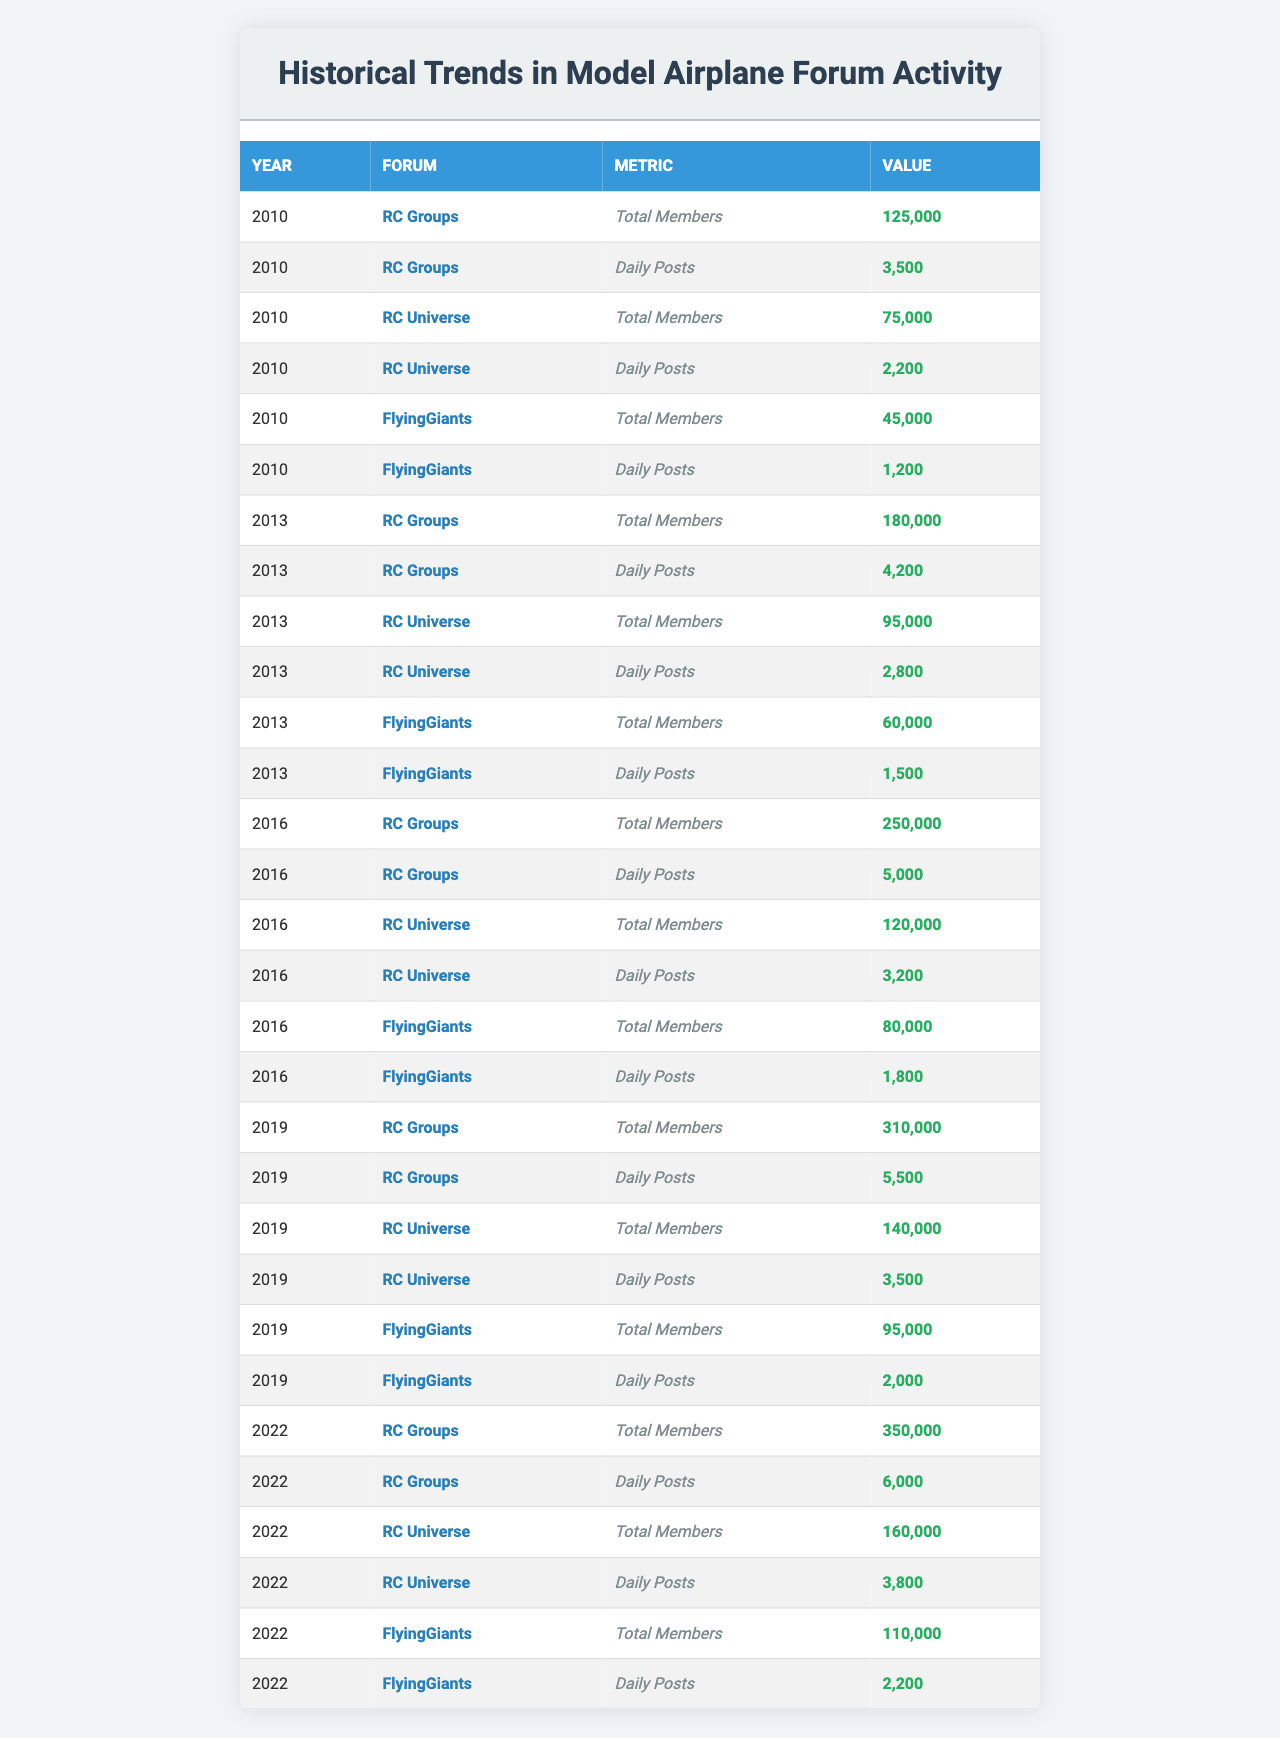What was the total number of members in the RC Groups forum in 2016? In the table, under the year 2016 and the forum RC Groups, the value for Total Members is listed as 250,000.
Answer: 250,000 Which forum had the highest daily posts in 2019? In 2019, the RC Groups forum had 5,500 daily posts, which is higher than the daily posts in RC Universe (3,500) and FlyingGiants (2,000).
Answer: RC Groups What is the total number of members across all three forums in 2022? To find this, we add the total members for each forum in 2022: 350,000 (RC Groups) + 160,000 (RC Universe) + 110,000 (FlyingGiants) = 620,000.
Answer: 620,000 Did the number of daily posts in RC Universe increase from 2010 to 2022? In 2010, RC Universe had 2,200 daily posts, and in 2022, it had 3,800 daily posts. Since 3,800 is greater than 2,200, the number of daily posts increased.
Answer: Yes What was the average number of daily posts across all forums in 2013? To find the average, first sum the daily posts in 2013: 4,200 (RC Groups) + 2,800 (RC Universe) + 1,500 (FlyingGiants) = 8,500. Then divide by 3 forums: 8,500 / 3 = 2,833.33. The average is approximately 2,833.
Answer: 2,833 Which forum showed the greatest growth in total members from 2010 to 2022? For RC Groups, growth is 350,000 - 125,000 = 225,000; for RC Universe, it's 160,000 - 75,000 = 85,000; and for FlyingGiants, it's 110,000 - 45,000 = 65,000. RC Groups had the largest growth of 225,000 members.
Answer: RC Groups Is the daily post activity in FlyingGiants higher or lower in 2016 compared to 2022? In 2016, FlyingGiants had 1,800 daily posts, while in 2022, it had 2,200 daily posts. Since 2,200 is greater than 1,800, the daily post activity increased.
Answer: Higher What percentage increase in total members did RC Universe experience from 2013 to 2019? The increase in total members is 140,000 (2019) - 95,000 (2013) = 45,000. The percentage increase is (45,000 / 95,000) * 100 = 47.37%.
Answer: 47.37% Which year saw the least number of daily posts in the FlyingGiants forum? Reviewing the FlyingGiants daily posts, in 2010 it had 1,200, 2013 had 1,500, 2016 had 1,800, 2019 had 2,000, and 2022 had 2,200. The least was in 2010 at 1,200 daily posts.
Answer: 2010 How much did the total number of members in RC Universe increase from 2016 to 2022? The total members for RC Universe in 2022 is 160,000 and in 2016 it was 120,000. The increase is 160,000 - 120,000 = 40,000.
Answer: 40,000 